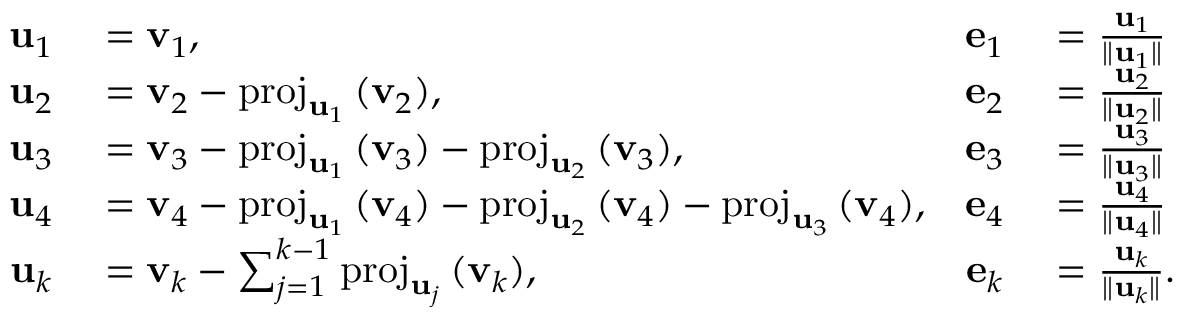<formula> <loc_0><loc_0><loc_500><loc_500>\begin{array} { r l r l } { u _ { 1 } } & = v _ { 1 } , } & { e _ { 1 } } & = { \frac { u _ { 1 } } { \| u _ { 1 } \| } } } \\ { u _ { 2 } } & = v _ { 2 } - p r o j _ { u _ { 1 } } \, ( v _ { 2 } ) , } & { e _ { 2 } } & = { \frac { u _ { 2 } } { \| u _ { 2 } \| } } } \\ { u _ { 3 } } & = v _ { 3 } - p r o j _ { u _ { 1 } } \, ( v _ { 3 } ) - p r o j _ { u _ { 2 } } \, ( v _ { 3 } ) , } & { e _ { 3 } } & = { \frac { u _ { 3 } } { \| u _ { 3 } \| } } } \\ { u _ { 4 } } & = v _ { 4 } - p r o j _ { u _ { 1 } } \, ( v _ { 4 } ) - p r o j _ { u _ { 2 } } \, ( v _ { 4 } ) - p r o j _ { u _ { 3 } } \, ( v _ { 4 } ) , } & { e _ { 4 } } & = { \frac { u _ { 4 } } { \| u _ { 4 } \| } } } \\ { u _ { k } } & = v _ { k } - \sum _ { j = 1 } ^ { k - 1 } p r o j _ { u _ { j } } \, ( v _ { k } ) , } & { e _ { k } } & = { \frac { u _ { k } } { \| u _ { k } \| } } . } \end{array}</formula> 